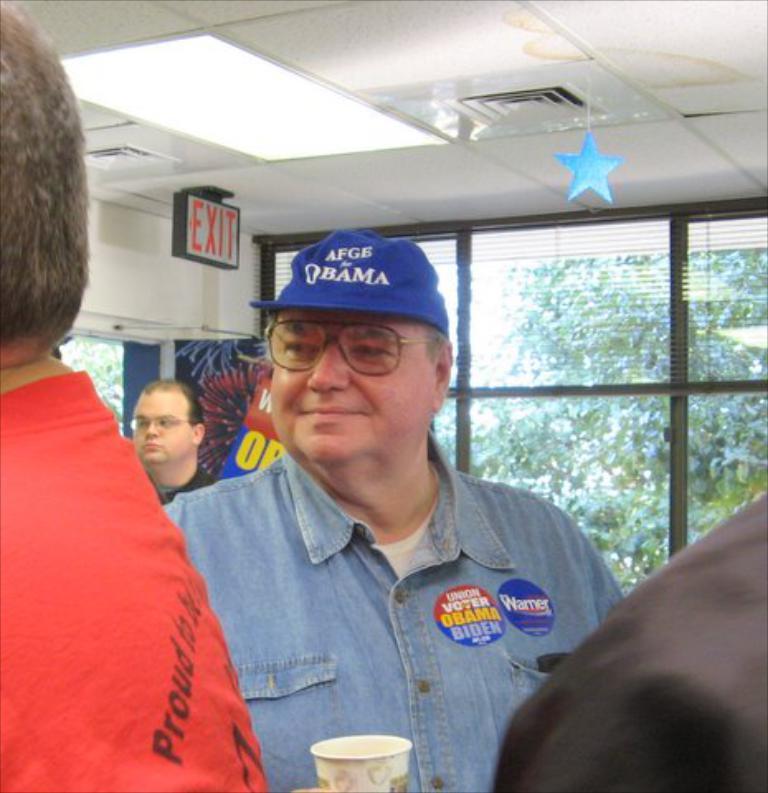How would you summarize this image in a sentence or two? In this image we can see a group of people standing. In that a man wearing a cap is holding a glass. On the backside we can see a wall, window, a board and a roof with a signboard and a star hanged to it. 